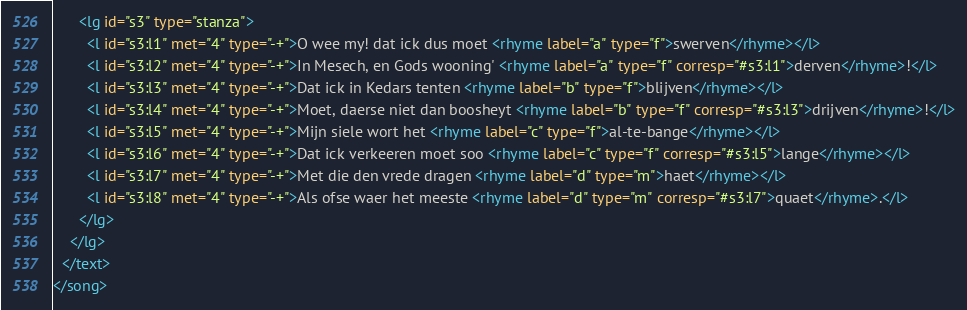Convert code to text. <code><loc_0><loc_0><loc_500><loc_500><_XML_>      <lg id="s3" type="stanza">
        <l id="s3:l1" met="4" type="-+">O wee my! dat ick dus moet <rhyme label="a" type="f">swerven</rhyme></l>
        <l id="s3:l2" met="4" type="-+">In Mesech, en Gods wooning' <rhyme label="a" type="f" corresp="#s3:l1">derven</rhyme>!</l>
        <l id="s3:l3" met="4" type="-+">Dat ick in Kedars tenten <rhyme label="b" type="f">blijven</rhyme></l>
        <l id="s3:l4" met="4" type="-+">Moet, daerse niet dan boosheyt <rhyme label="b" type="f" corresp="#s3:l3">drijven</rhyme>!</l>
        <l id="s3:l5" met="4" type="-+">Mijn siele wort het <rhyme label="c" type="f">al-te-bange</rhyme></l>
        <l id="s3:l6" met="4" type="-+">Dat ick verkeeren moet soo <rhyme label="c" type="f" corresp="#s3:l5">lange</rhyme></l>
        <l id="s3:l7" met="4" type="-+">Met die den vrede dragen <rhyme label="d" type="m">haet</rhyme></l>
        <l id="s3:l8" met="4" type="-+">Als ofse waer het meeste <rhyme label="d" type="m" corresp="#s3:l7">quaet</rhyme>.</l>
      </lg>
    </lg>
  </text>
</song>
</code> 